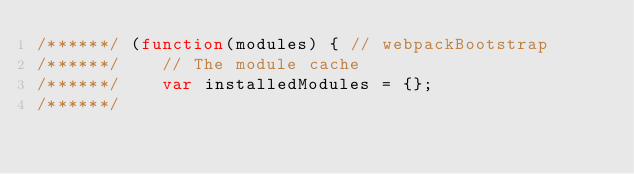Convert code to text. <code><loc_0><loc_0><loc_500><loc_500><_JavaScript_>/******/ (function(modules) { // webpackBootstrap
/******/ 	// The module cache
/******/ 	var installedModules = {};
/******/</code> 